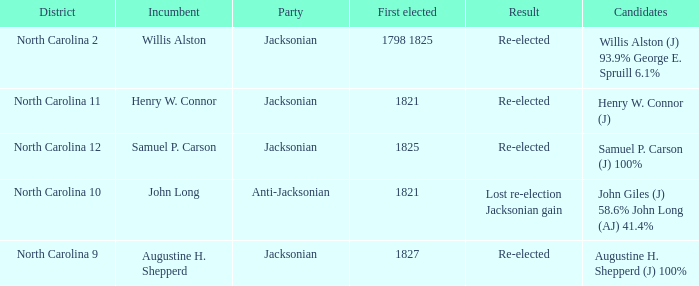9% and george e. spruill 1.0. 